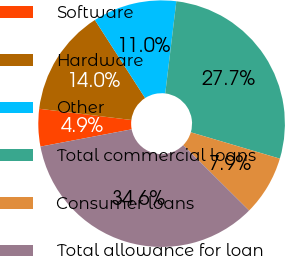Convert chart to OTSL. <chart><loc_0><loc_0><loc_500><loc_500><pie_chart><fcel>Software<fcel>Hardware<fcel>Other<fcel>Total commercial loans<fcel>Consumer loans<fcel>Total allowance for loan<nl><fcel>4.91%<fcel>13.97%<fcel>11.01%<fcel>27.67%<fcel>7.87%<fcel>34.57%<nl></chart> 